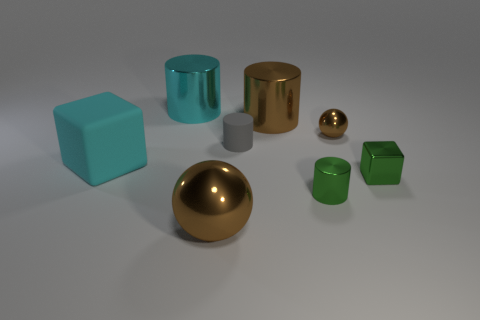Add 1 tiny brown cylinders. How many objects exist? 9 Subtract all balls. How many objects are left? 6 Add 5 big things. How many big things exist? 9 Subtract 0 blue cubes. How many objects are left? 8 Subtract all brown metal objects. Subtract all large yellow metal spheres. How many objects are left? 5 Add 3 big brown shiny things. How many big brown shiny things are left? 5 